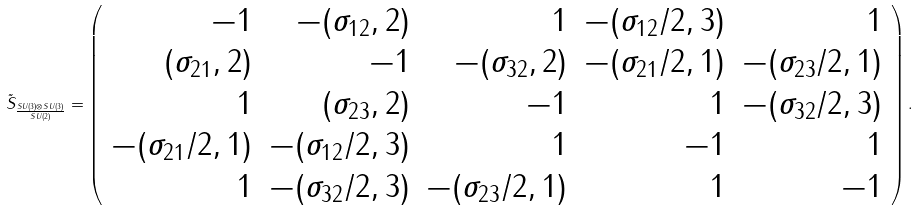<formula> <loc_0><loc_0><loc_500><loc_500>\tilde { S } _ { \frac { S U ( 3 ) \otimes S U ( 3 ) } { S U ( 2 ) } } = \left ( \begin{array} { r r r r r } - 1 & - ( \sigma _ { 1 2 } , 2 ) & 1 & - ( \sigma _ { 1 2 } / 2 , 3 ) & 1 \\ ( \sigma _ { 2 1 } , 2 ) & - 1 & - ( \sigma _ { 3 2 } , 2 ) & - ( \sigma _ { 2 1 } / 2 , 1 ) & - ( \sigma _ { 2 3 } / 2 , 1 ) \\ 1 & ( \sigma _ { 2 3 } , 2 ) & - 1 & 1 & - ( \sigma _ { 3 2 } / 2 , 3 ) \\ - ( \sigma _ { 2 1 } / 2 , 1 ) & - ( \sigma _ { 1 2 } / 2 , 3 ) & 1 & - 1 & 1 \\ 1 & - ( \sigma _ { 3 2 } / 2 , 3 ) & - ( \sigma _ { 2 3 } / 2 , 1 ) & 1 & - 1 \end{array} \right ) .</formula> 